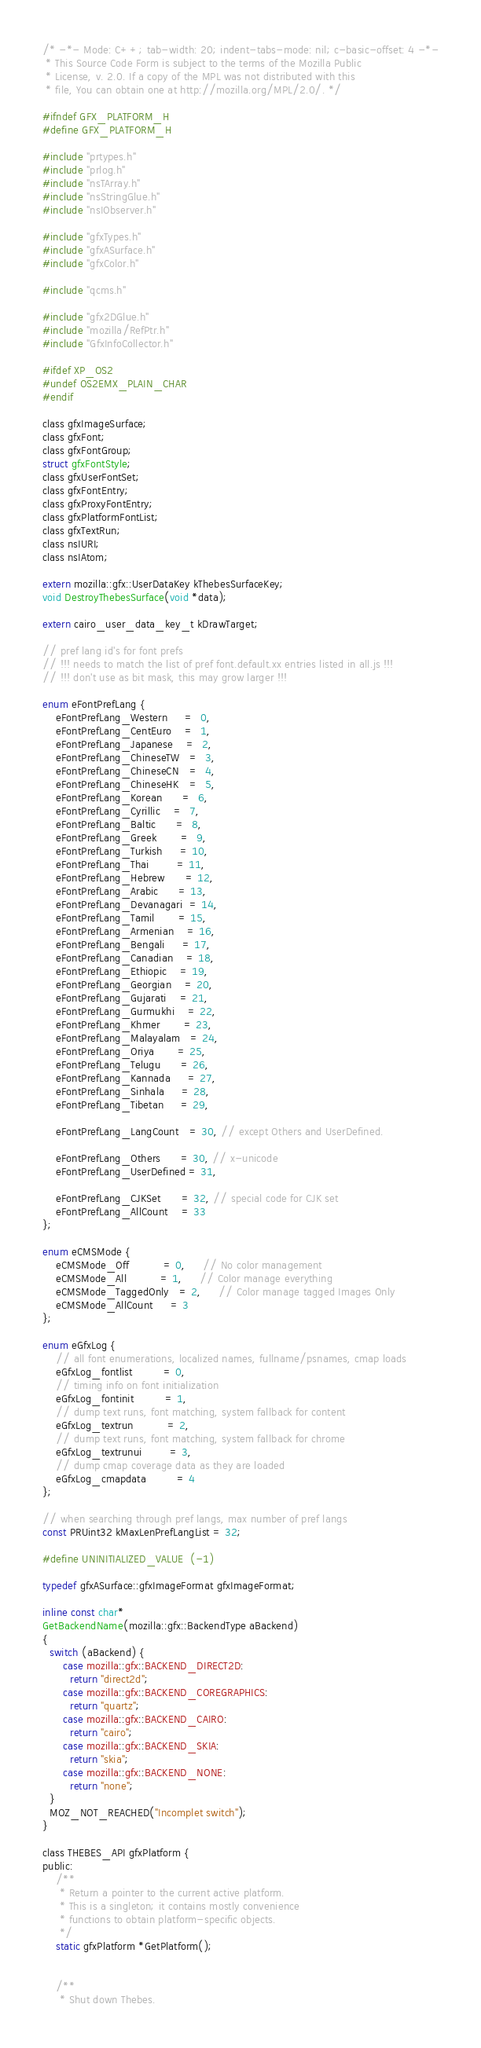Convert code to text. <code><loc_0><loc_0><loc_500><loc_500><_C_>/* -*- Mode: C++; tab-width: 20; indent-tabs-mode: nil; c-basic-offset: 4 -*-
 * This Source Code Form is subject to the terms of the Mozilla Public
 * License, v. 2.0. If a copy of the MPL was not distributed with this
 * file, You can obtain one at http://mozilla.org/MPL/2.0/. */

#ifndef GFX_PLATFORM_H
#define GFX_PLATFORM_H

#include "prtypes.h"
#include "prlog.h"
#include "nsTArray.h"
#include "nsStringGlue.h"
#include "nsIObserver.h"

#include "gfxTypes.h"
#include "gfxASurface.h"
#include "gfxColor.h"

#include "qcms.h"

#include "gfx2DGlue.h"
#include "mozilla/RefPtr.h"
#include "GfxInfoCollector.h"

#ifdef XP_OS2
#undef OS2EMX_PLAIN_CHAR
#endif

class gfxImageSurface;
class gfxFont;
class gfxFontGroup;
struct gfxFontStyle;
class gfxUserFontSet;
class gfxFontEntry;
class gfxProxyFontEntry;
class gfxPlatformFontList;
class gfxTextRun;
class nsIURI;
class nsIAtom;

extern mozilla::gfx::UserDataKey kThebesSurfaceKey;
void DestroyThebesSurface(void *data);

extern cairo_user_data_key_t kDrawTarget;

// pref lang id's for font prefs
// !!! needs to match the list of pref font.default.xx entries listed in all.js !!!
// !!! don't use as bit mask, this may grow larger !!!

enum eFontPrefLang {
    eFontPrefLang_Western     =  0,
    eFontPrefLang_CentEuro    =  1,
    eFontPrefLang_Japanese    =  2,
    eFontPrefLang_ChineseTW   =  3,
    eFontPrefLang_ChineseCN   =  4,
    eFontPrefLang_ChineseHK   =  5,
    eFontPrefLang_Korean      =  6,
    eFontPrefLang_Cyrillic    =  7,
    eFontPrefLang_Baltic      =  8,
    eFontPrefLang_Greek       =  9,
    eFontPrefLang_Turkish     = 10,
    eFontPrefLang_Thai        = 11,
    eFontPrefLang_Hebrew      = 12,
    eFontPrefLang_Arabic      = 13,
    eFontPrefLang_Devanagari  = 14,
    eFontPrefLang_Tamil       = 15,
    eFontPrefLang_Armenian    = 16,
    eFontPrefLang_Bengali     = 17,
    eFontPrefLang_Canadian    = 18,
    eFontPrefLang_Ethiopic    = 19,
    eFontPrefLang_Georgian    = 20,
    eFontPrefLang_Gujarati    = 21,
    eFontPrefLang_Gurmukhi    = 22,
    eFontPrefLang_Khmer       = 23,
    eFontPrefLang_Malayalam   = 24,
    eFontPrefLang_Oriya       = 25,
    eFontPrefLang_Telugu      = 26,
    eFontPrefLang_Kannada     = 27,
    eFontPrefLang_Sinhala     = 28,
    eFontPrefLang_Tibetan     = 29,

    eFontPrefLang_LangCount   = 30, // except Others and UserDefined.

    eFontPrefLang_Others      = 30, // x-unicode
    eFontPrefLang_UserDefined = 31,

    eFontPrefLang_CJKSet      = 32, // special code for CJK set
    eFontPrefLang_AllCount    = 33
};

enum eCMSMode {
    eCMSMode_Off          = 0,     // No color management
    eCMSMode_All          = 1,     // Color manage everything
    eCMSMode_TaggedOnly   = 2,     // Color manage tagged Images Only
    eCMSMode_AllCount     = 3
};

enum eGfxLog {
    // all font enumerations, localized names, fullname/psnames, cmap loads
    eGfxLog_fontlist         = 0,
    // timing info on font initialization
    eGfxLog_fontinit         = 1,
    // dump text runs, font matching, system fallback for content
    eGfxLog_textrun          = 2,
    // dump text runs, font matching, system fallback for chrome
    eGfxLog_textrunui        = 3,
    // dump cmap coverage data as they are loaded
    eGfxLog_cmapdata         = 4
};

// when searching through pref langs, max number of pref langs
const PRUint32 kMaxLenPrefLangList = 32;

#define UNINITIALIZED_VALUE  (-1)

typedef gfxASurface::gfxImageFormat gfxImageFormat;

inline const char*
GetBackendName(mozilla::gfx::BackendType aBackend)
{
  switch (aBackend) {
      case mozilla::gfx::BACKEND_DIRECT2D:
        return "direct2d";
      case mozilla::gfx::BACKEND_COREGRAPHICS:
        return "quartz";
      case mozilla::gfx::BACKEND_CAIRO:
        return "cairo";
      case mozilla::gfx::BACKEND_SKIA:
        return "skia";
      case mozilla::gfx::BACKEND_NONE:
        return "none";
  }
  MOZ_NOT_REACHED("Incomplet switch");
}

class THEBES_API gfxPlatform {
public:
    /**
     * Return a pointer to the current active platform.
     * This is a singleton; it contains mostly convenience
     * functions to obtain platform-specific objects.
     */
    static gfxPlatform *GetPlatform();


    /**
     * Shut down Thebes.</code> 